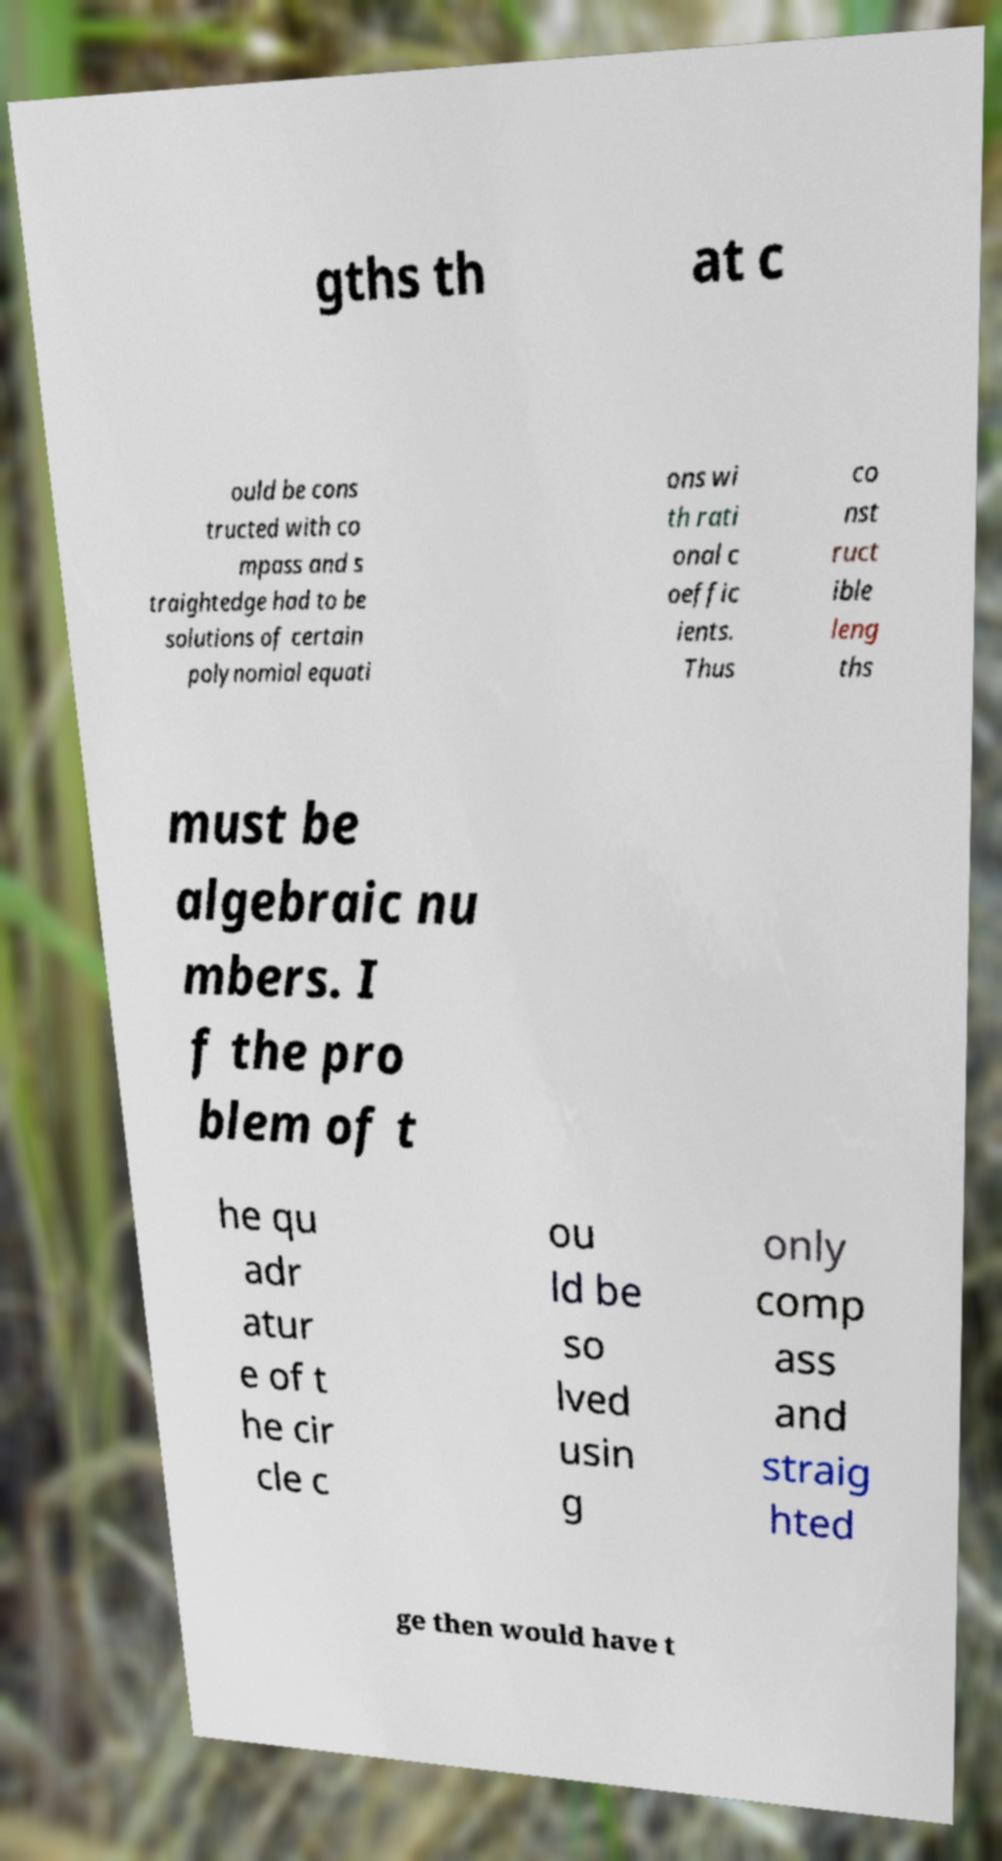Can you read and provide the text displayed in the image?This photo seems to have some interesting text. Can you extract and type it out for me? gths th at c ould be cons tructed with co mpass and s traightedge had to be solutions of certain polynomial equati ons wi th rati onal c oeffic ients. Thus co nst ruct ible leng ths must be algebraic nu mbers. I f the pro blem of t he qu adr atur e of t he cir cle c ou ld be so lved usin g only comp ass and straig hted ge then would have t 